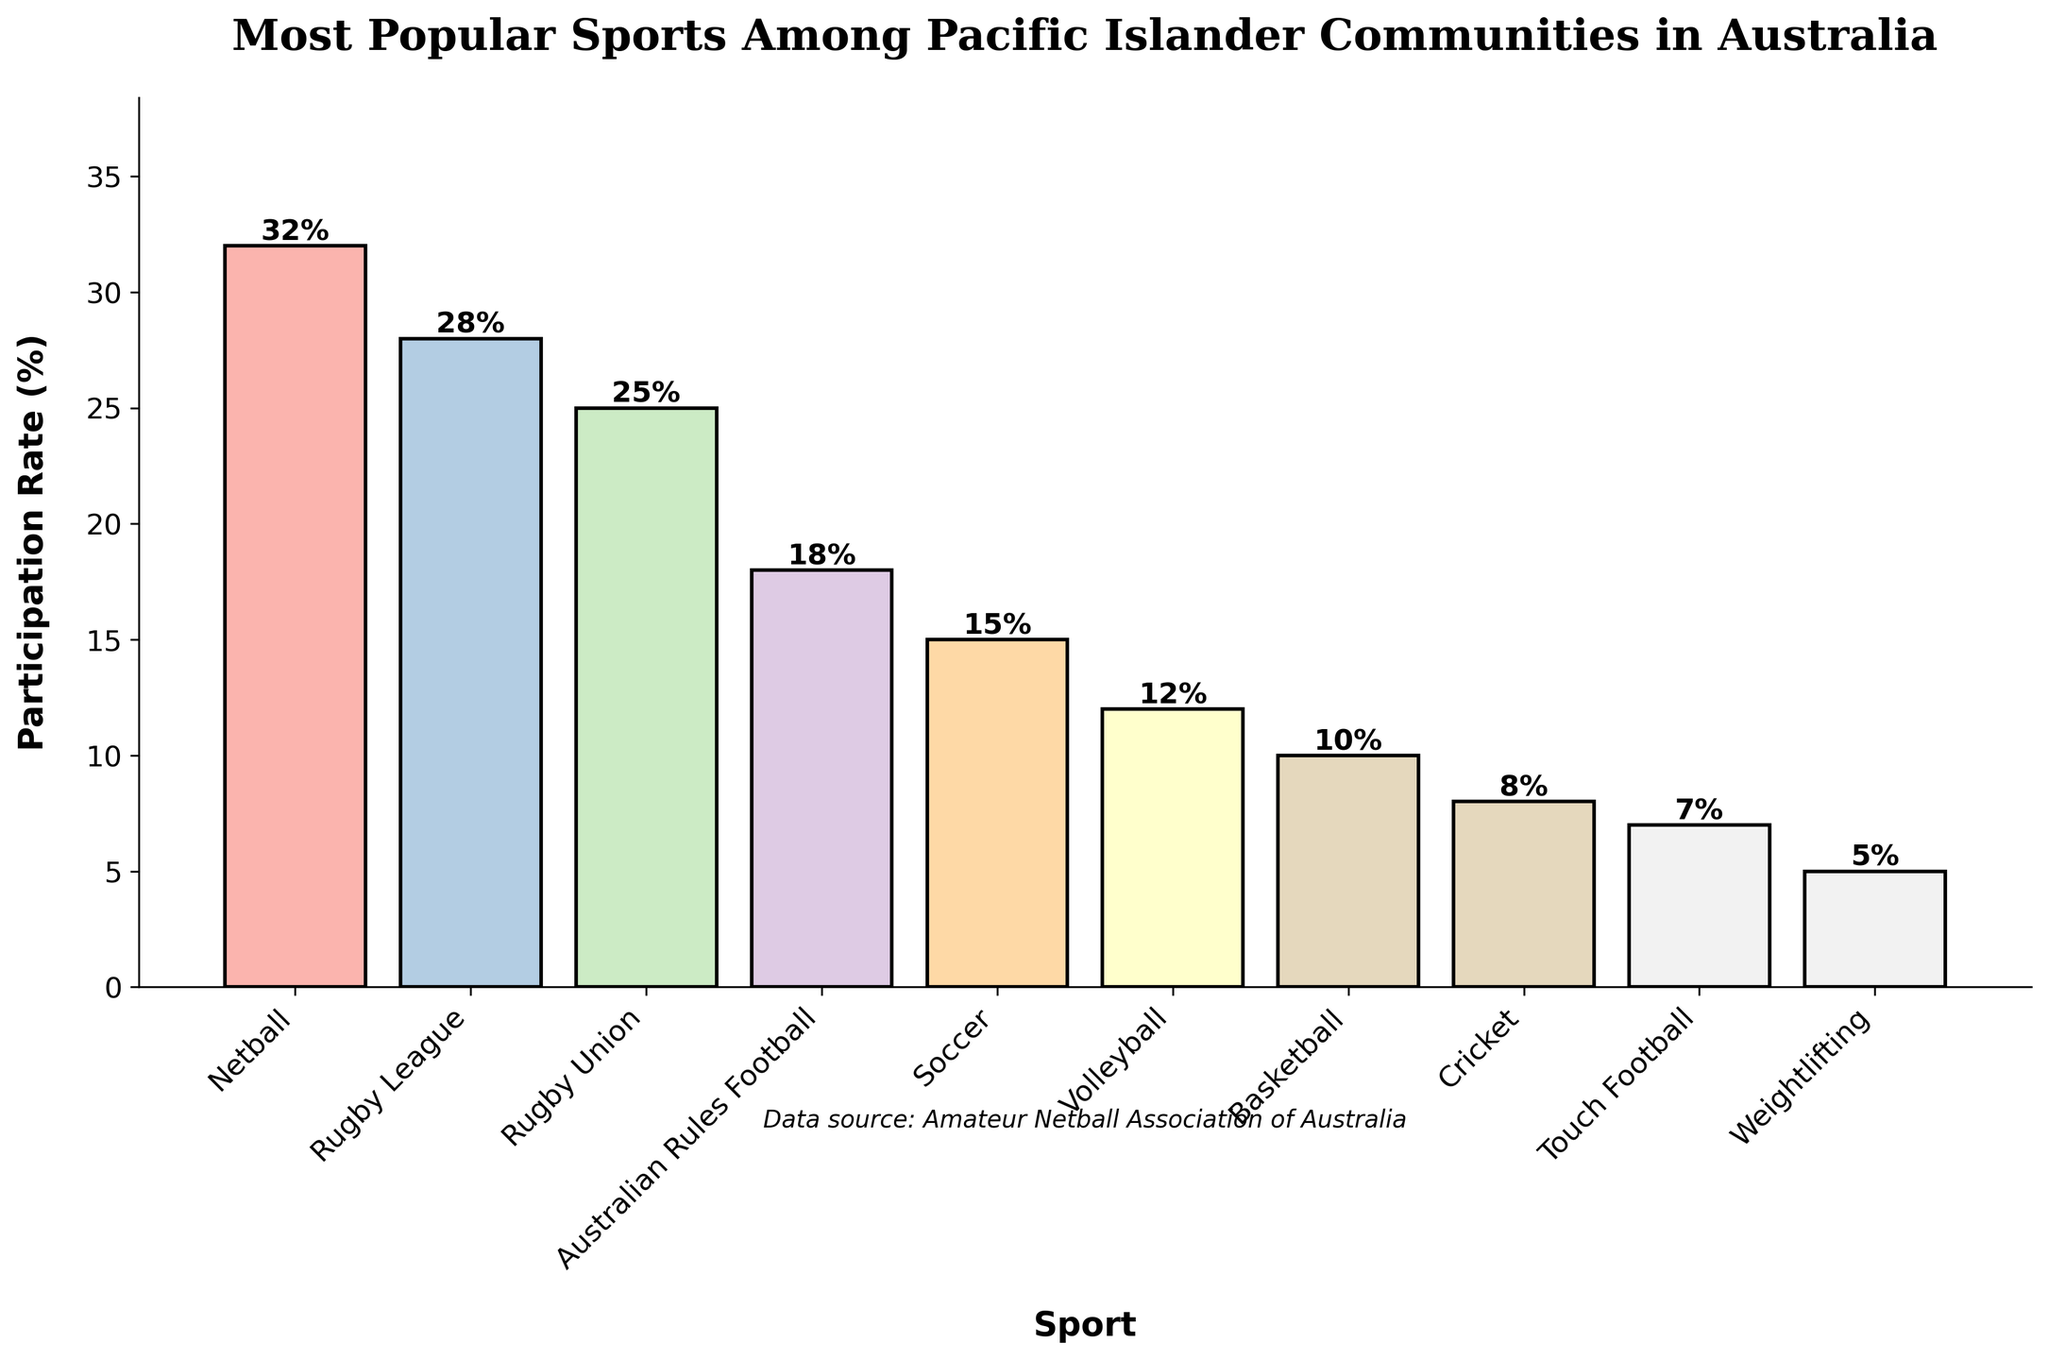What is the most popular sport among Pacific Islander communities in Australia? The highest bar represents the sport with the highest participation rate. The tallest bar corresponds to Netball with a participation rate of 32%.
Answer: Netball Which sport has a higher participation rate, Rugby Union or Volleyball? Compare the height of the bars for Rugby Union and Volleyball. Rugby Union has a participation rate of 25%, while Volleyball has a participation rate of 12%.
Answer: Rugby Union What is the combined participation rate for Rugby League and Australian Rules Football? Add the participation rates of Rugby League and Australian Rules Football. The rates are 28% and 18%, respectively, so the combined rate is 28% + 18% = 46%.
Answer: 46% How many sports have a participation rate lower than 10%? Identify the bars with a height corresponding to less than 10%. These sports are Cricket (8%), Touch Football (7%), and Weightlifting (5%). So, there are 3 sports.
Answer: 3 What is the difference in participation rate between Soccer and Basketball? Subtract the participation rate of Basketball from the participation rate of Soccer. Soccer has a rate of 15% and Basketball has a rate of 10%, so the difference is 15% - 10% = 5%.
Answer: 5% Which sport has a higher participation rate, Cricket or Touch Football? Compare the height of the bars for Cricket and Touch Football. Cricket has a participation rate of 8%, while Touch Football has a participation rate of 7%.
Answer: Cricket What is the average participation rate of the top three most popular sports? Calculate the average of the participation rates of Netball, Rugby League, and Rugby Union. Their rates are 32%, 28%, and 25%, respectively. The sum is 32% + 28% + 25% = 85%, and the average is 85% / 3 = 28.33%.
Answer: 28.33% What is the participation rate difference between the most and least popular sports? Subtract the participation rate of the least popular sport (Weightlifting) from the rate of the most popular sport (Netball). The difference is 32% - 5% = 27%.
Answer: 27% How many sports have a participation rate of more than 20%? Identify the bars with a height corresponding to more than 20%. These sports are Netball (32%), Rugby League (28%), and Rugby Union (25%). So, there are 3 sports.
Answer: 3 What is the participation rate of the sport that ranks fourth in popularity? Identify the sport with the fourth tallest bar. Australian Rules Football has the fourth highest participation rate at 18%.
Answer: 18% 